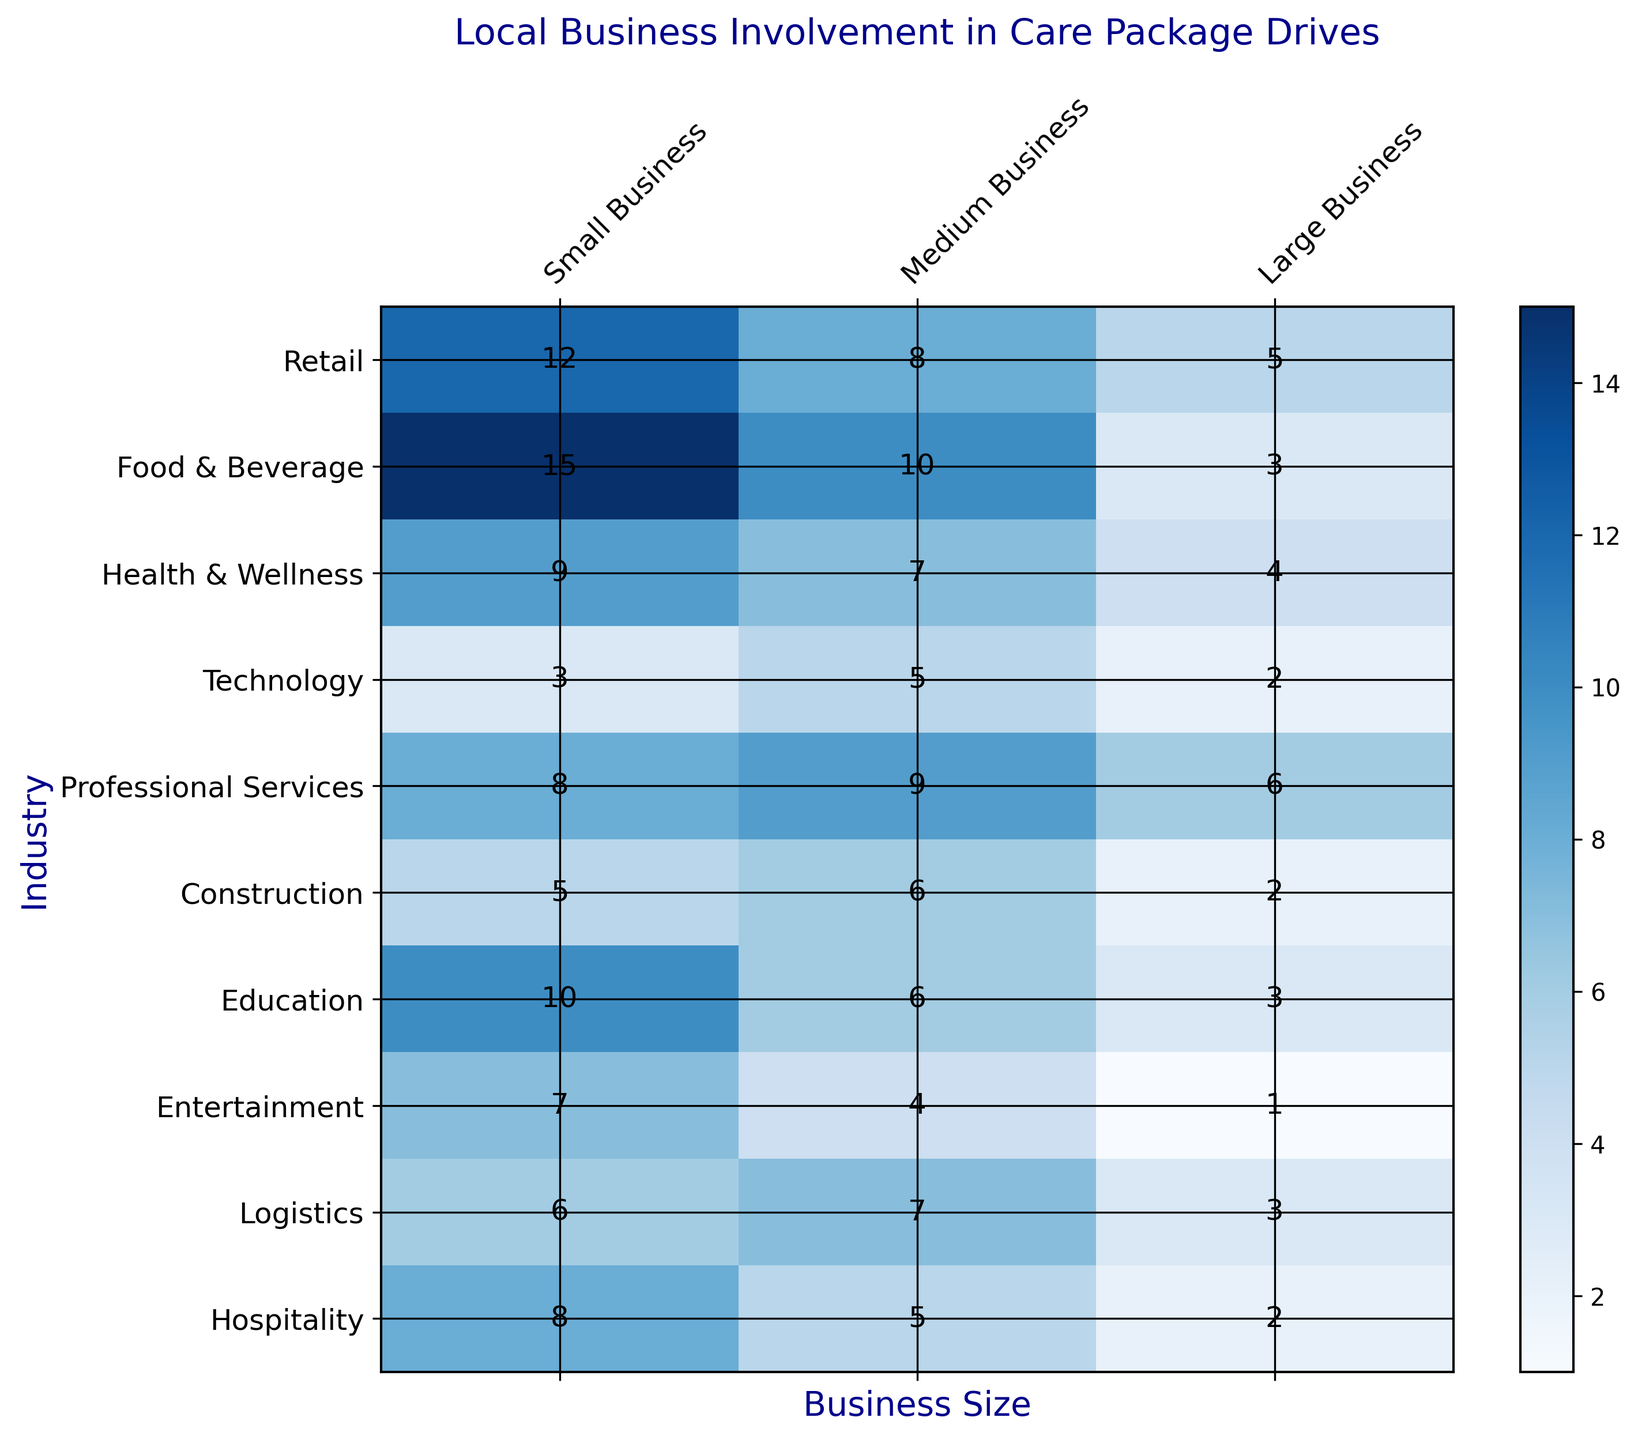Which industry has the highest involvement from small businesses? The Retail industry has the highest involvement from small businesses, as indicated by the darker shade of blue compared to others and the number '15'. Looking at the respective row for each industry in the 'Small Business' column confirms this visually.
Answer: Food & Beverage Which industry has the lowest involvement from large businesses? The Entertainment industry has the lowest involvement from large businesses, as indicated by the very lightest shade of blue and the number '1' in the respective cell of Entertainment's row and the 'Large Business' column.
Answer: Entertainment How many total businesses are involved in the Health & Wellness industry across all sizes? To get the total involvement, we sum the numbers in the Health & Wellness row: 9 (Small) + 7 (Medium) + 4 (Large). So, it's 9 + 7 + 4 = 20.
Answer: 20 Which industry has more involvement from medium businesses compared to small businesses? The Professional Services industry shows greater involvement from medium businesses (9) compared to small businesses (8), as indicated by the darker shade of blue for medium businesses in this category.
Answer: Professional Services In which industry do medium businesses have the least involvement? The Entertainment industry shows the least involvement from medium businesses, with the number '4' indicated by the lightest shade of blue in the 'Medium Business' column.
Answer: Entertainment What is the average involvement by small businesses across all industries? The total number of small businesses' involvement is calculated by summing the numbers in the 'Small Business' column: 12 + 15 + 9 + 3 + 8 + 5 + 10 + 7 + 6 + 8 = 83. There are 10 industries, so the average is 83 / 10 = 8.3.
Answer: 8.3 Which business size category has the highest involvement in the Education industry? Looking at the row for the Education industry, the numbers for small, medium, and large businesses are 10, 6, and 3, respectively. The highest is for small businesses, indicated by the darkest blue shade.
Answer: Small Business What is the difference between small and large businesses involved in the Logistics industry? The Logistics industry shows 6 small businesses and 3 large businesses. The difference is 6 - 3 = 3.
Answer: 3 Do large businesses have more involvement in the Technology industry compared to the Construction industry? Looking at the numbers for large businesses, Technology has 2 and Construction also has 2. They are equal in both industries.
Answer: No, they are equal How does the involvement of medium businesses in the Retail industry compare to those in the Health & Wellness industry? The Retail industry has 8 medium businesses involved, while Health & Wellness has 7. So, Retail has more involvement by just 1 business, as indicated by the slightly darker shade of blue.
Answer: Retail has more, by 1 